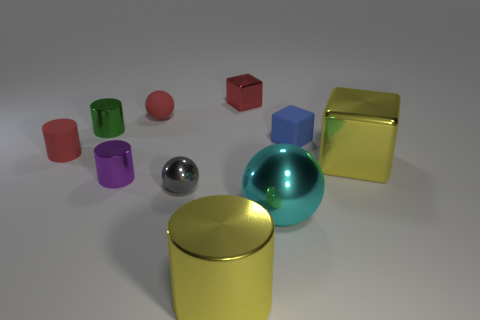Are there the same number of large blocks to the left of the large metal cylinder and tiny cylinders behind the purple thing?
Your answer should be very brief. No. Is there a red rubber sphere?
Your response must be concise. Yes. There is a yellow thing on the left side of the object that is behind the red rubber object that is on the right side of the green metallic object; what is its size?
Make the answer very short. Large. What is the shape of the red shiny object that is the same size as the red matte cylinder?
Give a very brief answer. Cube. What number of objects are things that are in front of the gray thing or large yellow objects?
Your answer should be very brief. 3. There is a yellow shiny thing that is behind the large yellow thing in front of the yellow block; are there any big shiny objects that are left of it?
Provide a succinct answer. Yes. How many tiny shiny things are there?
Give a very brief answer. 4. How many things are either tiny objects that are right of the large metal cylinder or red things behind the red cylinder?
Provide a succinct answer. 3. There is a yellow object right of the red metallic thing; is it the same size as the cyan metallic thing?
Your answer should be compact. Yes. What is the size of the yellow metallic thing that is the same shape as the small purple thing?
Offer a very short reply. Large. 